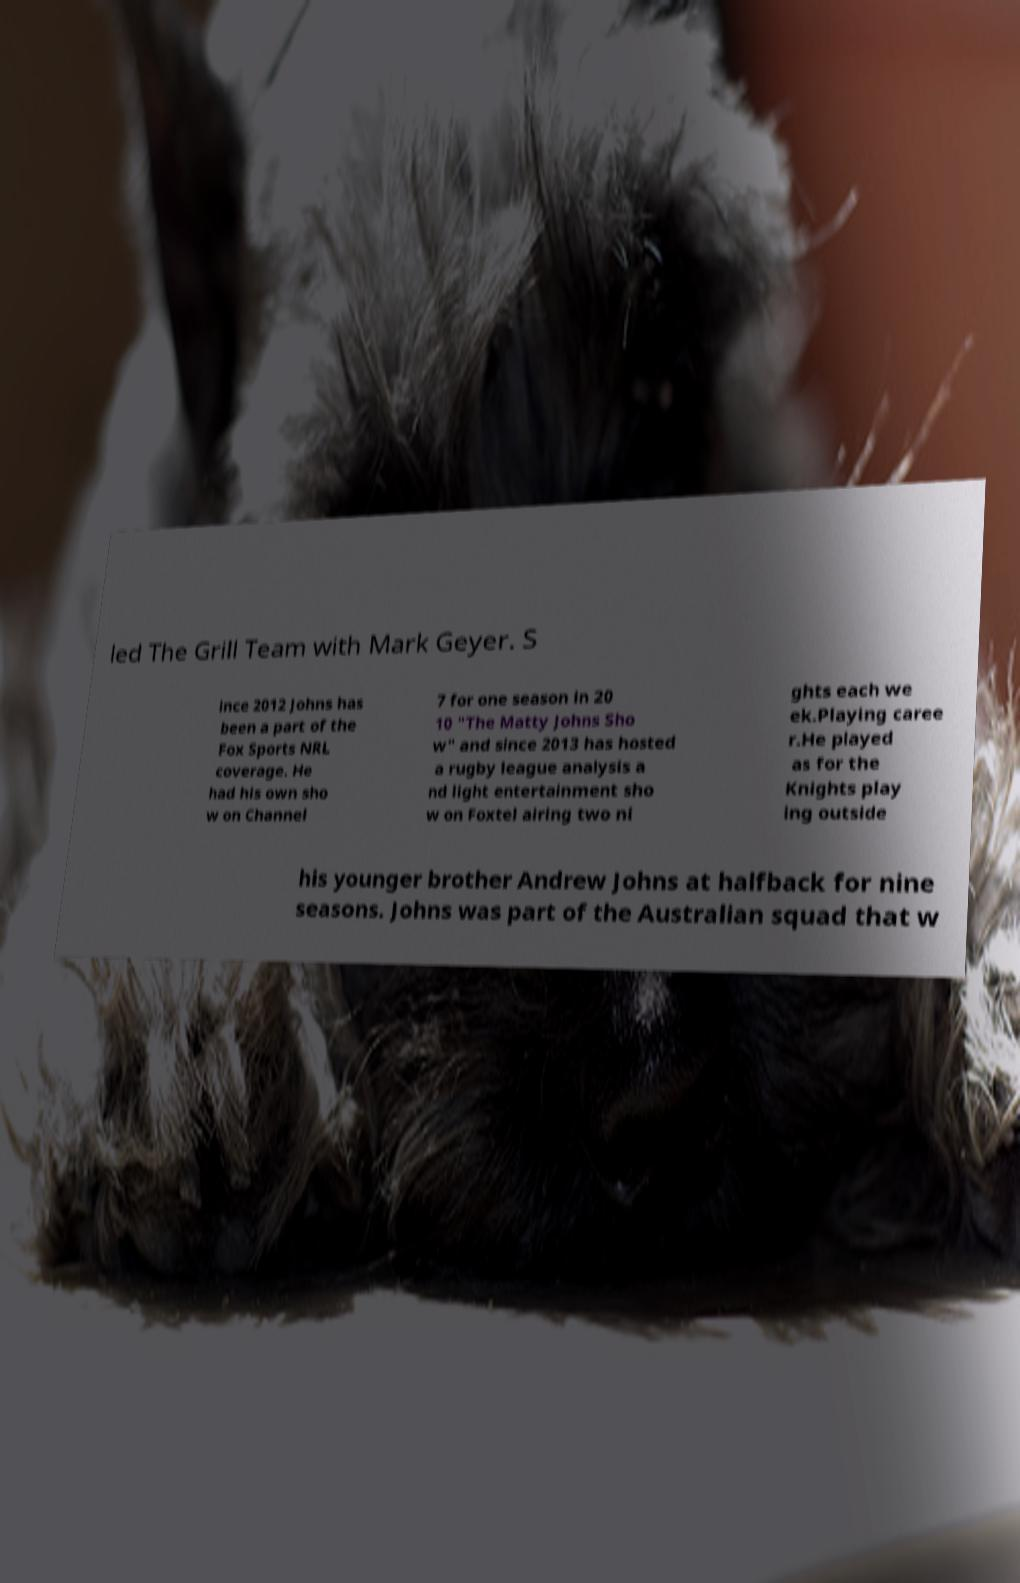For documentation purposes, I need the text within this image transcribed. Could you provide that? led The Grill Team with Mark Geyer. S ince 2012 Johns has been a part of the Fox Sports NRL coverage. He had his own sho w on Channel 7 for one season in 20 10 "The Matty Johns Sho w" and since 2013 has hosted a rugby league analysis a nd light entertainment sho w on Foxtel airing two ni ghts each we ek.Playing caree r.He played as for the Knights play ing outside his younger brother Andrew Johns at halfback for nine seasons. Johns was part of the Australian squad that w 